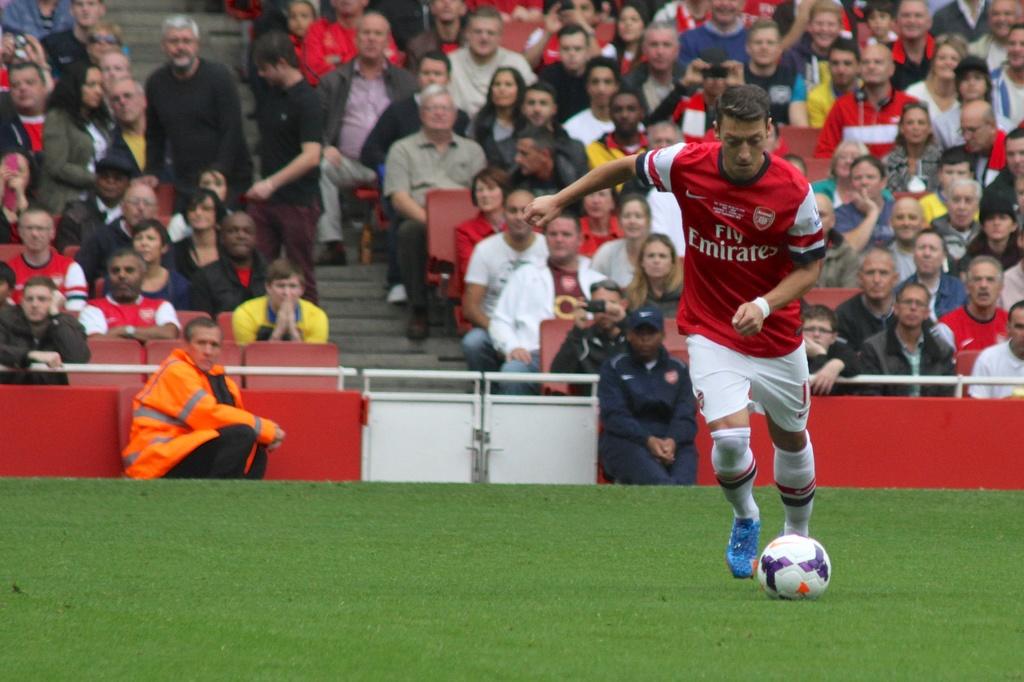What team is the player playing for?
Offer a very short reply. Emirates. Who is the sponser on the shirt for this team?
Your response must be concise. Emirates. 